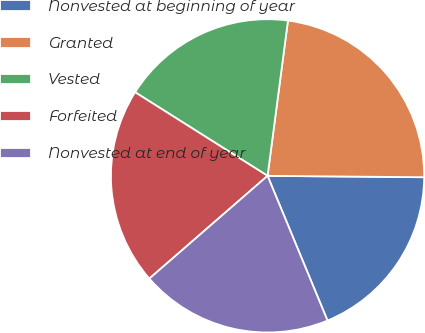Convert chart to OTSL. <chart><loc_0><loc_0><loc_500><loc_500><pie_chart><fcel>Nonvested at beginning of year<fcel>Granted<fcel>Vested<fcel>Forfeited<fcel>Nonvested at end of year<nl><fcel>18.61%<fcel>23.06%<fcel>18.12%<fcel>20.35%<fcel>19.86%<nl></chart> 